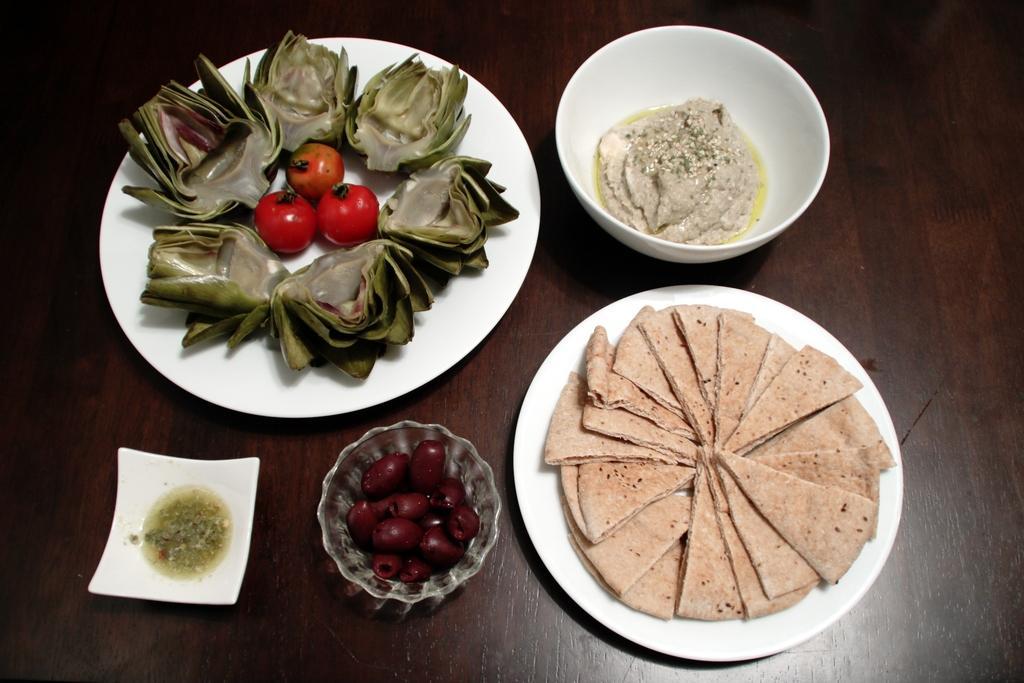Could you give a brief overview of what you see in this image? In this picture we can see plates, bowls, tomatoes and food on the wooden platform. 